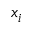<formula> <loc_0><loc_0><loc_500><loc_500>x _ { i }</formula> 